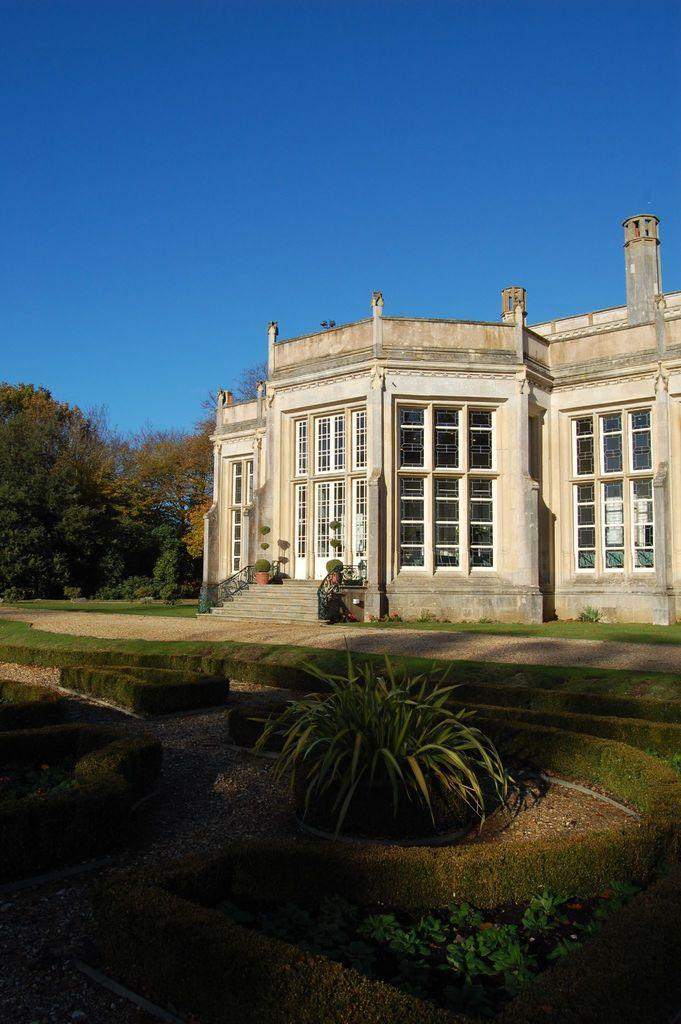What is the main structure in the image? There is a big building in the image. What type of vegetation can be seen in the image? There are trees, grass, and plants in the image. How many brothers are sitting on the grass in the image? There are no brothers present in the image; it only features a big building, trees, grass, and plants. 